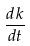<formula> <loc_0><loc_0><loc_500><loc_500>\frac { d k } { d t }</formula> 